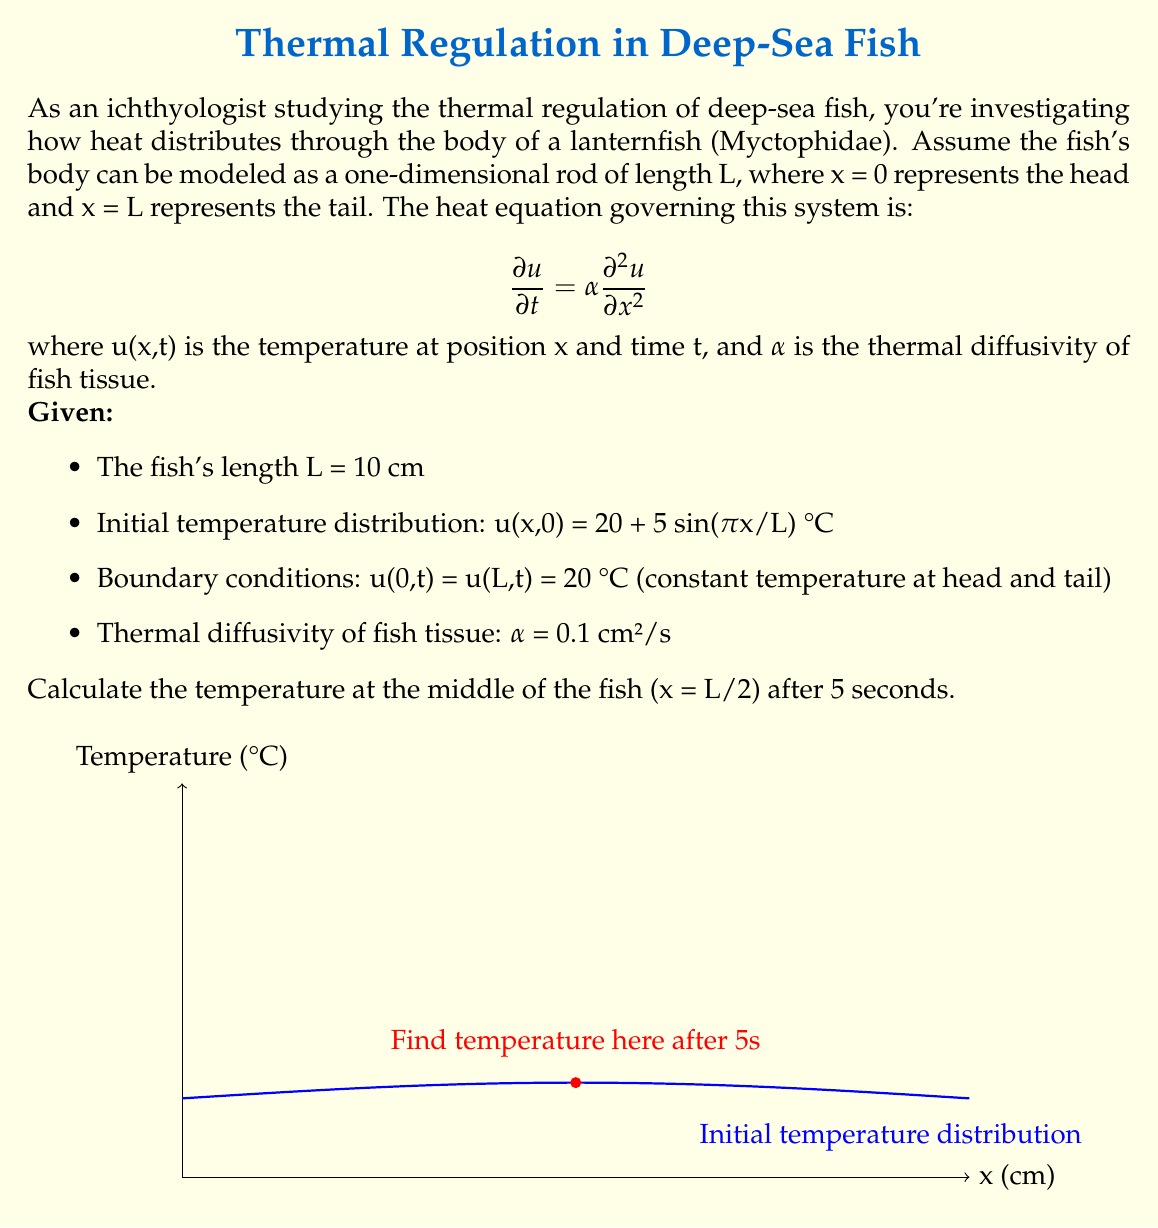Give your solution to this math problem. To solve this problem, we'll use the method of separation of variables for the heat equation.

Step 1: Separate variables
Let u(x,t) = X(x)T(t). Substituting into the heat equation:
$$X(x)T'(t) = \alpha X''(x)T(t)$$
$$\frac{T'(t)}{T(t)} = \alpha \frac{X''(x)}{X(x)} = -\lambda$$

Step 2: Solve the spatial equation
$$X''(x) + \lambda X(x) = 0$$
With boundary conditions X(0) = X(L) = 0, we get:
$$X_n(x) = \sin(\frac{n\pi x}{L}), \lambda_n = (\frac{n\pi}{L})^2$$

Step 3: Solve the temporal equation
$$T'(t) + \alpha \lambda_n T(t) = 0$$
$$T_n(t) = e^{-\alpha \lambda_n t} = e^{-\alpha (\frac{n\pi}{L})^2 t}$$

Step 4: Combine solutions
$$u(x,t) = \sum_{n=1}^{\infty} b_n \sin(\frac{n\pi x}{L}) e^{-\alpha (\frac{n\pi}{L})^2 t}$$

Step 5: Find coefficients using initial condition
$$u(x,0) = 20 + 5 \sin(\frac{\pi x}{L}) = \sum_{n=1}^{\infty} b_n \sin(\frac{n\pi x}{L})$$
Therefore, b₁ = 5, and all other bₙ = 0.

Step 6: Final solution
$$u(x,t) = 20 + 5 \sin(\frac{\pi x}{L}) e^{-\alpha (\frac{\pi}{L})^2 t}$$

Step 7: Calculate temperature at x = L/2, t = 5s
$$u(L/2, 5) = 20 + 5 \sin(\frac{\pi}{2}) e^{-0.1 (\frac{\pi}{10})^2 5}$$
$$= 20 + 5 \cdot 1 \cdot e^{-0.1 \cdot 0.0987 \cdot 5}$$
$$= 20 + 5 \cdot e^{-0.04935}$$
$$= 20 + 5 \cdot 0.9518$$
$$= 24.76 \text{ °C}$$
Answer: 24.76 °C 